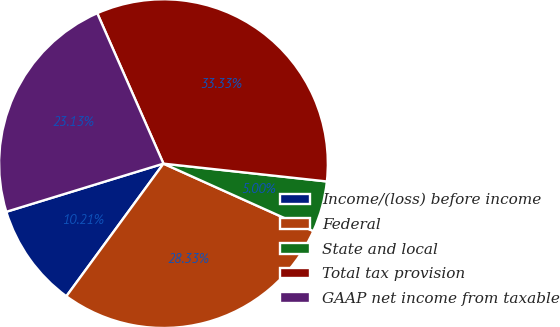<chart> <loc_0><loc_0><loc_500><loc_500><pie_chart><fcel>Income/(loss) before income<fcel>Federal<fcel>State and local<fcel>Total tax provision<fcel>GAAP net income from taxable<nl><fcel>10.21%<fcel>28.33%<fcel>5.0%<fcel>33.33%<fcel>23.13%<nl></chart> 